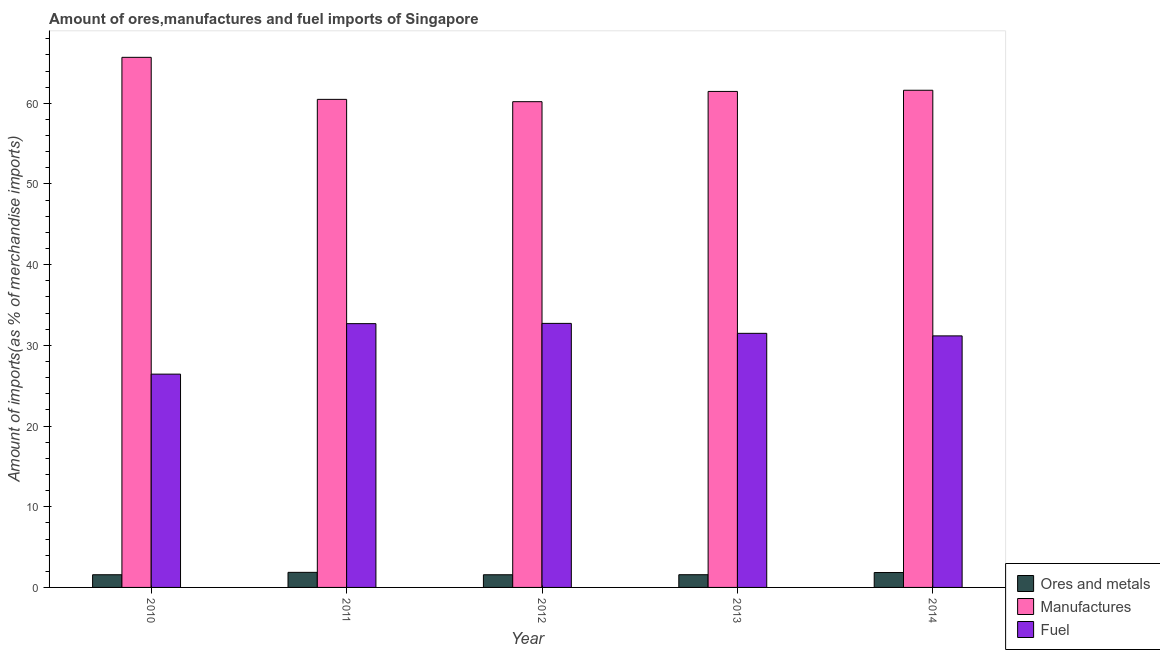How many bars are there on the 4th tick from the left?
Keep it short and to the point. 3. What is the percentage of fuel imports in 2011?
Provide a succinct answer. 32.69. Across all years, what is the maximum percentage of fuel imports?
Your answer should be very brief. 32.72. Across all years, what is the minimum percentage of manufactures imports?
Your answer should be very brief. 60.2. In which year was the percentage of manufactures imports maximum?
Your answer should be very brief. 2010. What is the total percentage of ores and metals imports in the graph?
Offer a very short reply. 8.43. What is the difference between the percentage of fuel imports in 2010 and that in 2014?
Your response must be concise. -4.74. What is the difference between the percentage of manufactures imports in 2010 and the percentage of fuel imports in 2014?
Your response must be concise. 4.08. What is the average percentage of manufactures imports per year?
Offer a very short reply. 61.89. In the year 2010, what is the difference between the percentage of manufactures imports and percentage of fuel imports?
Ensure brevity in your answer.  0. What is the ratio of the percentage of manufactures imports in 2010 to that in 2014?
Ensure brevity in your answer.  1.07. Is the percentage of ores and metals imports in 2010 less than that in 2013?
Offer a very short reply. Yes. Is the difference between the percentage of ores and metals imports in 2012 and 2014 greater than the difference between the percentage of manufactures imports in 2012 and 2014?
Your response must be concise. No. What is the difference between the highest and the second highest percentage of manufactures imports?
Keep it short and to the point. 4.08. What is the difference between the highest and the lowest percentage of fuel imports?
Keep it short and to the point. 6.29. In how many years, is the percentage of fuel imports greater than the average percentage of fuel imports taken over all years?
Keep it short and to the point. 4. Is the sum of the percentage of manufactures imports in 2012 and 2014 greater than the maximum percentage of fuel imports across all years?
Ensure brevity in your answer.  Yes. What does the 1st bar from the left in 2013 represents?
Your response must be concise. Ores and metals. What does the 2nd bar from the right in 2010 represents?
Keep it short and to the point. Manufactures. Is it the case that in every year, the sum of the percentage of ores and metals imports and percentage of manufactures imports is greater than the percentage of fuel imports?
Keep it short and to the point. Yes. How many bars are there?
Your response must be concise. 15. How many years are there in the graph?
Keep it short and to the point. 5. Are the values on the major ticks of Y-axis written in scientific E-notation?
Keep it short and to the point. No. Where does the legend appear in the graph?
Offer a terse response. Bottom right. How many legend labels are there?
Your response must be concise. 3. What is the title of the graph?
Provide a succinct answer. Amount of ores,manufactures and fuel imports of Singapore. Does "Infant(male)" appear as one of the legend labels in the graph?
Keep it short and to the point. No. What is the label or title of the Y-axis?
Provide a succinct answer. Amount of imports(as % of merchandise imports). What is the Amount of imports(as % of merchandise imports) in Ores and metals in 2010?
Offer a terse response. 1.57. What is the Amount of imports(as % of merchandise imports) in Manufactures in 2010?
Your answer should be compact. 65.7. What is the Amount of imports(as % of merchandise imports) of Fuel in 2010?
Your response must be concise. 26.43. What is the Amount of imports(as % of merchandise imports) in Ores and metals in 2011?
Your answer should be very brief. 1.87. What is the Amount of imports(as % of merchandise imports) of Manufactures in 2011?
Give a very brief answer. 60.49. What is the Amount of imports(as % of merchandise imports) in Fuel in 2011?
Provide a succinct answer. 32.69. What is the Amount of imports(as % of merchandise imports) of Ores and metals in 2012?
Give a very brief answer. 1.57. What is the Amount of imports(as % of merchandise imports) in Manufactures in 2012?
Your response must be concise. 60.2. What is the Amount of imports(as % of merchandise imports) of Fuel in 2012?
Offer a very short reply. 32.72. What is the Amount of imports(as % of merchandise imports) in Ores and metals in 2013?
Your answer should be very brief. 1.58. What is the Amount of imports(as % of merchandise imports) of Manufactures in 2013?
Ensure brevity in your answer.  61.47. What is the Amount of imports(as % of merchandise imports) in Fuel in 2013?
Keep it short and to the point. 31.49. What is the Amount of imports(as % of merchandise imports) of Ores and metals in 2014?
Keep it short and to the point. 1.85. What is the Amount of imports(as % of merchandise imports) in Manufactures in 2014?
Provide a short and direct response. 61.62. What is the Amount of imports(as % of merchandise imports) in Fuel in 2014?
Ensure brevity in your answer.  31.18. Across all years, what is the maximum Amount of imports(as % of merchandise imports) of Ores and metals?
Ensure brevity in your answer.  1.87. Across all years, what is the maximum Amount of imports(as % of merchandise imports) of Manufactures?
Provide a short and direct response. 65.7. Across all years, what is the maximum Amount of imports(as % of merchandise imports) in Fuel?
Your answer should be compact. 32.72. Across all years, what is the minimum Amount of imports(as % of merchandise imports) of Ores and metals?
Make the answer very short. 1.57. Across all years, what is the minimum Amount of imports(as % of merchandise imports) of Manufactures?
Offer a very short reply. 60.2. Across all years, what is the minimum Amount of imports(as % of merchandise imports) of Fuel?
Provide a short and direct response. 26.43. What is the total Amount of imports(as % of merchandise imports) in Ores and metals in the graph?
Your answer should be very brief. 8.43. What is the total Amount of imports(as % of merchandise imports) in Manufactures in the graph?
Your answer should be very brief. 309.47. What is the total Amount of imports(as % of merchandise imports) in Fuel in the graph?
Offer a terse response. 154.52. What is the difference between the Amount of imports(as % of merchandise imports) in Ores and metals in 2010 and that in 2011?
Provide a succinct answer. -0.3. What is the difference between the Amount of imports(as % of merchandise imports) of Manufactures in 2010 and that in 2011?
Ensure brevity in your answer.  5.21. What is the difference between the Amount of imports(as % of merchandise imports) in Fuel in 2010 and that in 2011?
Your answer should be very brief. -6.26. What is the difference between the Amount of imports(as % of merchandise imports) of Ores and metals in 2010 and that in 2012?
Give a very brief answer. 0. What is the difference between the Amount of imports(as % of merchandise imports) in Manufactures in 2010 and that in 2012?
Ensure brevity in your answer.  5.5. What is the difference between the Amount of imports(as % of merchandise imports) of Fuel in 2010 and that in 2012?
Provide a short and direct response. -6.29. What is the difference between the Amount of imports(as % of merchandise imports) of Ores and metals in 2010 and that in 2013?
Offer a terse response. -0. What is the difference between the Amount of imports(as % of merchandise imports) of Manufactures in 2010 and that in 2013?
Your answer should be compact. 4.23. What is the difference between the Amount of imports(as % of merchandise imports) in Fuel in 2010 and that in 2013?
Provide a short and direct response. -5.06. What is the difference between the Amount of imports(as % of merchandise imports) of Ores and metals in 2010 and that in 2014?
Provide a succinct answer. -0.27. What is the difference between the Amount of imports(as % of merchandise imports) in Manufactures in 2010 and that in 2014?
Provide a short and direct response. 4.08. What is the difference between the Amount of imports(as % of merchandise imports) of Fuel in 2010 and that in 2014?
Provide a succinct answer. -4.74. What is the difference between the Amount of imports(as % of merchandise imports) in Ores and metals in 2011 and that in 2012?
Your answer should be very brief. 0.3. What is the difference between the Amount of imports(as % of merchandise imports) of Manufactures in 2011 and that in 2012?
Provide a short and direct response. 0.29. What is the difference between the Amount of imports(as % of merchandise imports) of Fuel in 2011 and that in 2012?
Ensure brevity in your answer.  -0.03. What is the difference between the Amount of imports(as % of merchandise imports) of Ores and metals in 2011 and that in 2013?
Offer a terse response. 0.29. What is the difference between the Amount of imports(as % of merchandise imports) in Manufactures in 2011 and that in 2013?
Ensure brevity in your answer.  -0.98. What is the difference between the Amount of imports(as % of merchandise imports) in Fuel in 2011 and that in 2013?
Offer a terse response. 1.2. What is the difference between the Amount of imports(as % of merchandise imports) of Ores and metals in 2011 and that in 2014?
Your answer should be compact. 0.02. What is the difference between the Amount of imports(as % of merchandise imports) in Manufactures in 2011 and that in 2014?
Make the answer very short. -1.13. What is the difference between the Amount of imports(as % of merchandise imports) of Fuel in 2011 and that in 2014?
Offer a terse response. 1.52. What is the difference between the Amount of imports(as % of merchandise imports) in Ores and metals in 2012 and that in 2013?
Provide a succinct answer. -0.01. What is the difference between the Amount of imports(as % of merchandise imports) in Manufactures in 2012 and that in 2013?
Give a very brief answer. -1.27. What is the difference between the Amount of imports(as % of merchandise imports) in Fuel in 2012 and that in 2013?
Offer a terse response. 1.23. What is the difference between the Amount of imports(as % of merchandise imports) of Ores and metals in 2012 and that in 2014?
Provide a succinct answer. -0.28. What is the difference between the Amount of imports(as % of merchandise imports) in Manufactures in 2012 and that in 2014?
Ensure brevity in your answer.  -1.42. What is the difference between the Amount of imports(as % of merchandise imports) of Fuel in 2012 and that in 2014?
Your answer should be very brief. 1.55. What is the difference between the Amount of imports(as % of merchandise imports) of Ores and metals in 2013 and that in 2014?
Your answer should be compact. -0.27. What is the difference between the Amount of imports(as % of merchandise imports) of Manufactures in 2013 and that in 2014?
Offer a terse response. -0.15. What is the difference between the Amount of imports(as % of merchandise imports) of Fuel in 2013 and that in 2014?
Provide a short and direct response. 0.31. What is the difference between the Amount of imports(as % of merchandise imports) in Ores and metals in 2010 and the Amount of imports(as % of merchandise imports) in Manufactures in 2011?
Give a very brief answer. -58.91. What is the difference between the Amount of imports(as % of merchandise imports) in Ores and metals in 2010 and the Amount of imports(as % of merchandise imports) in Fuel in 2011?
Provide a short and direct response. -31.12. What is the difference between the Amount of imports(as % of merchandise imports) in Manufactures in 2010 and the Amount of imports(as % of merchandise imports) in Fuel in 2011?
Give a very brief answer. 33.01. What is the difference between the Amount of imports(as % of merchandise imports) of Ores and metals in 2010 and the Amount of imports(as % of merchandise imports) of Manufactures in 2012?
Your answer should be very brief. -58.63. What is the difference between the Amount of imports(as % of merchandise imports) in Ores and metals in 2010 and the Amount of imports(as % of merchandise imports) in Fuel in 2012?
Provide a succinct answer. -31.15. What is the difference between the Amount of imports(as % of merchandise imports) of Manufactures in 2010 and the Amount of imports(as % of merchandise imports) of Fuel in 2012?
Give a very brief answer. 32.97. What is the difference between the Amount of imports(as % of merchandise imports) in Ores and metals in 2010 and the Amount of imports(as % of merchandise imports) in Manufactures in 2013?
Offer a terse response. -59.9. What is the difference between the Amount of imports(as % of merchandise imports) of Ores and metals in 2010 and the Amount of imports(as % of merchandise imports) of Fuel in 2013?
Provide a short and direct response. -29.92. What is the difference between the Amount of imports(as % of merchandise imports) of Manufactures in 2010 and the Amount of imports(as % of merchandise imports) of Fuel in 2013?
Provide a short and direct response. 34.21. What is the difference between the Amount of imports(as % of merchandise imports) of Ores and metals in 2010 and the Amount of imports(as % of merchandise imports) of Manufactures in 2014?
Provide a succinct answer. -60.04. What is the difference between the Amount of imports(as % of merchandise imports) of Ores and metals in 2010 and the Amount of imports(as % of merchandise imports) of Fuel in 2014?
Your answer should be compact. -29.6. What is the difference between the Amount of imports(as % of merchandise imports) in Manufactures in 2010 and the Amount of imports(as % of merchandise imports) in Fuel in 2014?
Provide a short and direct response. 34.52. What is the difference between the Amount of imports(as % of merchandise imports) of Ores and metals in 2011 and the Amount of imports(as % of merchandise imports) of Manufactures in 2012?
Your response must be concise. -58.33. What is the difference between the Amount of imports(as % of merchandise imports) of Ores and metals in 2011 and the Amount of imports(as % of merchandise imports) of Fuel in 2012?
Your response must be concise. -30.86. What is the difference between the Amount of imports(as % of merchandise imports) in Manufactures in 2011 and the Amount of imports(as % of merchandise imports) in Fuel in 2012?
Give a very brief answer. 27.76. What is the difference between the Amount of imports(as % of merchandise imports) of Ores and metals in 2011 and the Amount of imports(as % of merchandise imports) of Manufactures in 2013?
Your answer should be compact. -59.6. What is the difference between the Amount of imports(as % of merchandise imports) in Ores and metals in 2011 and the Amount of imports(as % of merchandise imports) in Fuel in 2013?
Offer a very short reply. -29.62. What is the difference between the Amount of imports(as % of merchandise imports) of Manufactures in 2011 and the Amount of imports(as % of merchandise imports) of Fuel in 2013?
Your answer should be very brief. 29. What is the difference between the Amount of imports(as % of merchandise imports) of Ores and metals in 2011 and the Amount of imports(as % of merchandise imports) of Manufactures in 2014?
Ensure brevity in your answer.  -59.75. What is the difference between the Amount of imports(as % of merchandise imports) of Ores and metals in 2011 and the Amount of imports(as % of merchandise imports) of Fuel in 2014?
Keep it short and to the point. -29.31. What is the difference between the Amount of imports(as % of merchandise imports) in Manufactures in 2011 and the Amount of imports(as % of merchandise imports) in Fuel in 2014?
Your answer should be very brief. 29.31. What is the difference between the Amount of imports(as % of merchandise imports) in Ores and metals in 2012 and the Amount of imports(as % of merchandise imports) in Manufactures in 2013?
Make the answer very short. -59.9. What is the difference between the Amount of imports(as % of merchandise imports) of Ores and metals in 2012 and the Amount of imports(as % of merchandise imports) of Fuel in 2013?
Ensure brevity in your answer.  -29.92. What is the difference between the Amount of imports(as % of merchandise imports) in Manufactures in 2012 and the Amount of imports(as % of merchandise imports) in Fuel in 2013?
Your answer should be very brief. 28.71. What is the difference between the Amount of imports(as % of merchandise imports) of Ores and metals in 2012 and the Amount of imports(as % of merchandise imports) of Manufactures in 2014?
Provide a short and direct response. -60.05. What is the difference between the Amount of imports(as % of merchandise imports) of Ores and metals in 2012 and the Amount of imports(as % of merchandise imports) of Fuel in 2014?
Provide a succinct answer. -29.61. What is the difference between the Amount of imports(as % of merchandise imports) of Manufactures in 2012 and the Amount of imports(as % of merchandise imports) of Fuel in 2014?
Make the answer very short. 29.03. What is the difference between the Amount of imports(as % of merchandise imports) of Ores and metals in 2013 and the Amount of imports(as % of merchandise imports) of Manufactures in 2014?
Ensure brevity in your answer.  -60.04. What is the difference between the Amount of imports(as % of merchandise imports) in Ores and metals in 2013 and the Amount of imports(as % of merchandise imports) in Fuel in 2014?
Provide a short and direct response. -29.6. What is the difference between the Amount of imports(as % of merchandise imports) of Manufactures in 2013 and the Amount of imports(as % of merchandise imports) of Fuel in 2014?
Your response must be concise. 30.3. What is the average Amount of imports(as % of merchandise imports) of Ores and metals per year?
Make the answer very short. 1.69. What is the average Amount of imports(as % of merchandise imports) in Manufactures per year?
Make the answer very short. 61.89. What is the average Amount of imports(as % of merchandise imports) in Fuel per year?
Offer a very short reply. 30.9. In the year 2010, what is the difference between the Amount of imports(as % of merchandise imports) in Ores and metals and Amount of imports(as % of merchandise imports) in Manufactures?
Offer a very short reply. -64.13. In the year 2010, what is the difference between the Amount of imports(as % of merchandise imports) in Ores and metals and Amount of imports(as % of merchandise imports) in Fuel?
Provide a short and direct response. -24.86. In the year 2010, what is the difference between the Amount of imports(as % of merchandise imports) of Manufactures and Amount of imports(as % of merchandise imports) of Fuel?
Ensure brevity in your answer.  39.26. In the year 2011, what is the difference between the Amount of imports(as % of merchandise imports) in Ores and metals and Amount of imports(as % of merchandise imports) in Manufactures?
Give a very brief answer. -58.62. In the year 2011, what is the difference between the Amount of imports(as % of merchandise imports) of Ores and metals and Amount of imports(as % of merchandise imports) of Fuel?
Your answer should be compact. -30.82. In the year 2011, what is the difference between the Amount of imports(as % of merchandise imports) in Manufactures and Amount of imports(as % of merchandise imports) in Fuel?
Your answer should be compact. 27.79. In the year 2012, what is the difference between the Amount of imports(as % of merchandise imports) of Ores and metals and Amount of imports(as % of merchandise imports) of Manufactures?
Offer a terse response. -58.63. In the year 2012, what is the difference between the Amount of imports(as % of merchandise imports) in Ores and metals and Amount of imports(as % of merchandise imports) in Fuel?
Offer a terse response. -31.15. In the year 2012, what is the difference between the Amount of imports(as % of merchandise imports) of Manufactures and Amount of imports(as % of merchandise imports) of Fuel?
Provide a short and direct response. 27.48. In the year 2013, what is the difference between the Amount of imports(as % of merchandise imports) in Ores and metals and Amount of imports(as % of merchandise imports) in Manufactures?
Ensure brevity in your answer.  -59.89. In the year 2013, what is the difference between the Amount of imports(as % of merchandise imports) in Ores and metals and Amount of imports(as % of merchandise imports) in Fuel?
Keep it short and to the point. -29.91. In the year 2013, what is the difference between the Amount of imports(as % of merchandise imports) in Manufactures and Amount of imports(as % of merchandise imports) in Fuel?
Your answer should be very brief. 29.98. In the year 2014, what is the difference between the Amount of imports(as % of merchandise imports) of Ores and metals and Amount of imports(as % of merchandise imports) of Manufactures?
Offer a terse response. -59.77. In the year 2014, what is the difference between the Amount of imports(as % of merchandise imports) of Ores and metals and Amount of imports(as % of merchandise imports) of Fuel?
Offer a very short reply. -29.33. In the year 2014, what is the difference between the Amount of imports(as % of merchandise imports) in Manufactures and Amount of imports(as % of merchandise imports) in Fuel?
Your answer should be very brief. 30.44. What is the ratio of the Amount of imports(as % of merchandise imports) of Ores and metals in 2010 to that in 2011?
Provide a succinct answer. 0.84. What is the ratio of the Amount of imports(as % of merchandise imports) in Manufactures in 2010 to that in 2011?
Give a very brief answer. 1.09. What is the ratio of the Amount of imports(as % of merchandise imports) in Fuel in 2010 to that in 2011?
Your answer should be compact. 0.81. What is the ratio of the Amount of imports(as % of merchandise imports) in Ores and metals in 2010 to that in 2012?
Offer a very short reply. 1. What is the ratio of the Amount of imports(as % of merchandise imports) of Manufactures in 2010 to that in 2012?
Offer a terse response. 1.09. What is the ratio of the Amount of imports(as % of merchandise imports) of Fuel in 2010 to that in 2012?
Keep it short and to the point. 0.81. What is the ratio of the Amount of imports(as % of merchandise imports) in Ores and metals in 2010 to that in 2013?
Give a very brief answer. 1. What is the ratio of the Amount of imports(as % of merchandise imports) of Manufactures in 2010 to that in 2013?
Provide a succinct answer. 1.07. What is the ratio of the Amount of imports(as % of merchandise imports) in Fuel in 2010 to that in 2013?
Your answer should be compact. 0.84. What is the ratio of the Amount of imports(as % of merchandise imports) of Ores and metals in 2010 to that in 2014?
Your answer should be compact. 0.85. What is the ratio of the Amount of imports(as % of merchandise imports) in Manufactures in 2010 to that in 2014?
Keep it short and to the point. 1.07. What is the ratio of the Amount of imports(as % of merchandise imports) in Fuel in 2010 to that in 2014?
Your answer should be very brief. 0.85. What is the ratio of the Amount of imports(as % of merchandise imports) of Ores and metals in 2011 to that in 2012?
Make the answer very short. 1.19. What is the ratio of the Amount of imports(as % of merchandise imports) in Fuel in 2011 to that in 2012?
Give a very brief answer. 1. What is the ratio of the Amount of imports(as % of merchandise imports) in Ores and metals in 2011 to that in 2013?
Offer a terse response. 1.18. What is the ratio of the Amount of imports(as % of merchandise imports) of Manufactures in 2011 to that in 2013?
Give a very brief answer. 0.98. What is the ratio of the Amount of imports(as % of merchandise imports) of Fuel in 2011 to that in 2013?
Your response must be concise. 1.04. What is the ratio of the Amount of imports(as % of merchandise imports) of Ores and metals in 2011 to that in 2014?
Provide a succinct answer. 1.01. What is the ratio of the Amount of imports(as % of merchandise imports) of Manufactures in 2011 to that in 2014?
Ensure brevity in your answer.  0.98. What is the ratio of the Amount of imports(as % of merchandise imports) of Fuel in 2011 to that in 2014?
Offer a very short reply. 1.05. What is the ratio of the Amount of imports(as % of merchandise imports) in Ores and metals in 2012 to that in 2013?
Your answer should be compact. 1. What is the ratio of the Amount of imports(as % of merchandise imports) of Manufactures in 2012 to that in 2013?
Your response must be concise. 0.98. What is the ratio of the Amount of imports(as % of merchandise imports) of Fuel in 2012 to that in 2013?
Keep it short and to the point. 1.04. What is the ratio of the Amount of imports(as % of merchandise imports) of Ores and metals in 2012 to that in 2014?
Provide a short and direct response. 0.85. What is the ratio of the Amount of imports(as % of merchandise imports) in Fuel in 2012 to that in 2014?
Ensure brevity in your answer.  1.05. What is the ratio of the Amount of imports(as % of merchandise imports) in Ores and metals in 2013 to that in 2014?
Your answer should be compact. 0.85. What is the ratio of the Amount of imports(as % of merchandise imports) of Fuel in 2013 to that in 2014?
Make the answer very short. 1.01. What is the difference between the highest and the second highest Amount of imports(as % of merchandise imports) of Ores and metals?
Your answer should be compact. 0.02. What is the difference between the highest and the second highest Amount of imports(as % of merchandise imports) of Manufactures?
Give a very brief answer. 4.08. What is the difference between the highest and the second highest Amount of imports(as % of merchandise imports) of Fuel?
Make the answer very short. 0.03. What is the difference between the highest and the lowest Amount of imports(as % of merchandise imports) in Ores and metals?
Make the answer very short. 0.3. What is the difference between the highest and the lowest Amount of imports(as % of merchandise imports) of Manufactures?
Provide a short and direct response. 5.5. What is the difference between the highest and the lowest Amount of imports(as % of merchandise imports) of Fuel?
Your answer should be compact. 6.29. 